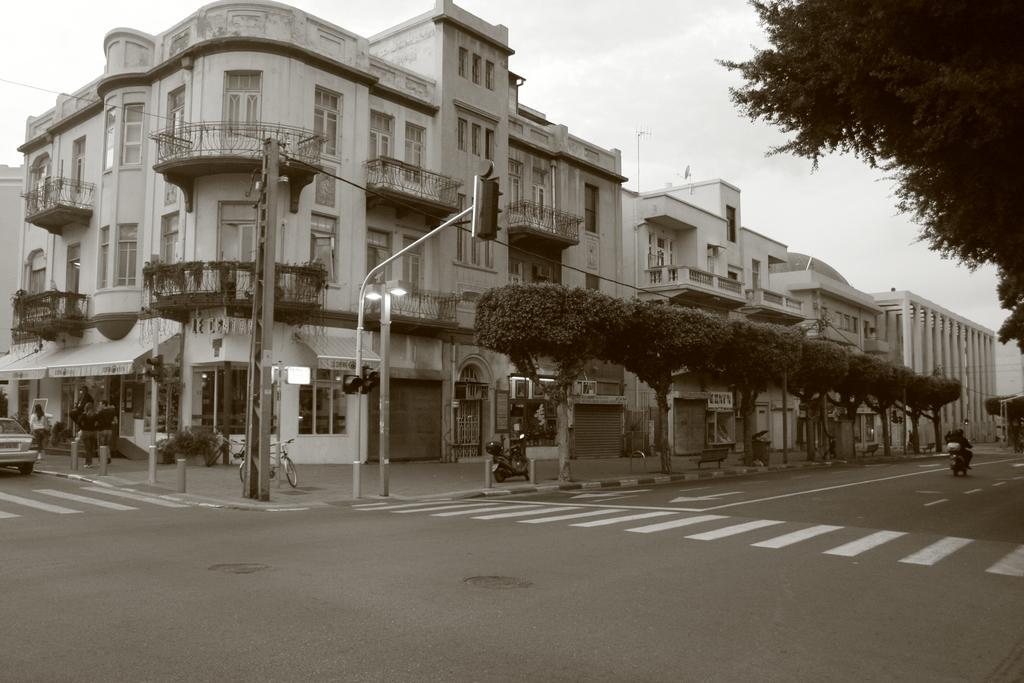Describe this image in one or two sentences. This image is a black and white image. This image is taken outdoors. At the top of the image there is the sky with clouds. At the bottom of the image there is a road. In the middle of the image there are many buildings. There are many plants in the pots. There are many trees. A few people are walking on the sidewalk. A bicycle and a bike are parked on the sidewalk. There are a few poles with street lights and signal lights. On the right side of the image a person is riding on the bike. On the left side of the image a car is parked on the road. 